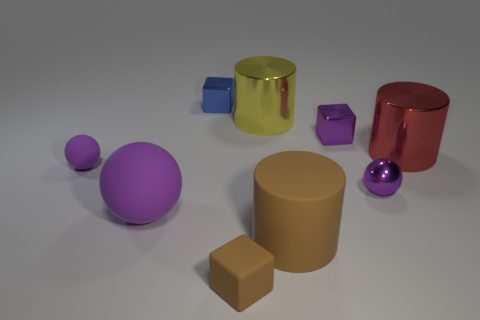Is the number of purple shiny cubes less than the number of spheres?
Ensure brevity in your answer.  Yes. How many other things are the same material as the small blue cube?
Your answer should be very brief. 4. What size is the other purple rubber thing that is the same shape as the big purple object?
Your response must be concise. Small. Is the material of the large object that is behind the purple metal block the same as the tiny purple thing that is left of the small matte cube?
Your answer should be very brief. No. Are there fewer tiny brown rubber blocks behind the purple block than big cyan shiny cylinders?
Give a very brief answer. No. Is there any other thing that is the same shape as the large yellow metal thing?
Offer a terse response. Yes. What color is the tiny matte thing that is the same shape as the small blue metal object?
Ensure brevity in your answer.  Brown. Is the size of the sphere that is right of the blue cube the same as the tiny brown block?
Provide a short and direct response. Yes. What size is the purple object behind the shiny cylinder on the right side of the small purple metallic cube?
Your answer should be very brief. Small. Do the purple cube and the large object that is on the right side of the brown cylinder have the same material?
Your answer should be very brief. Yes. 